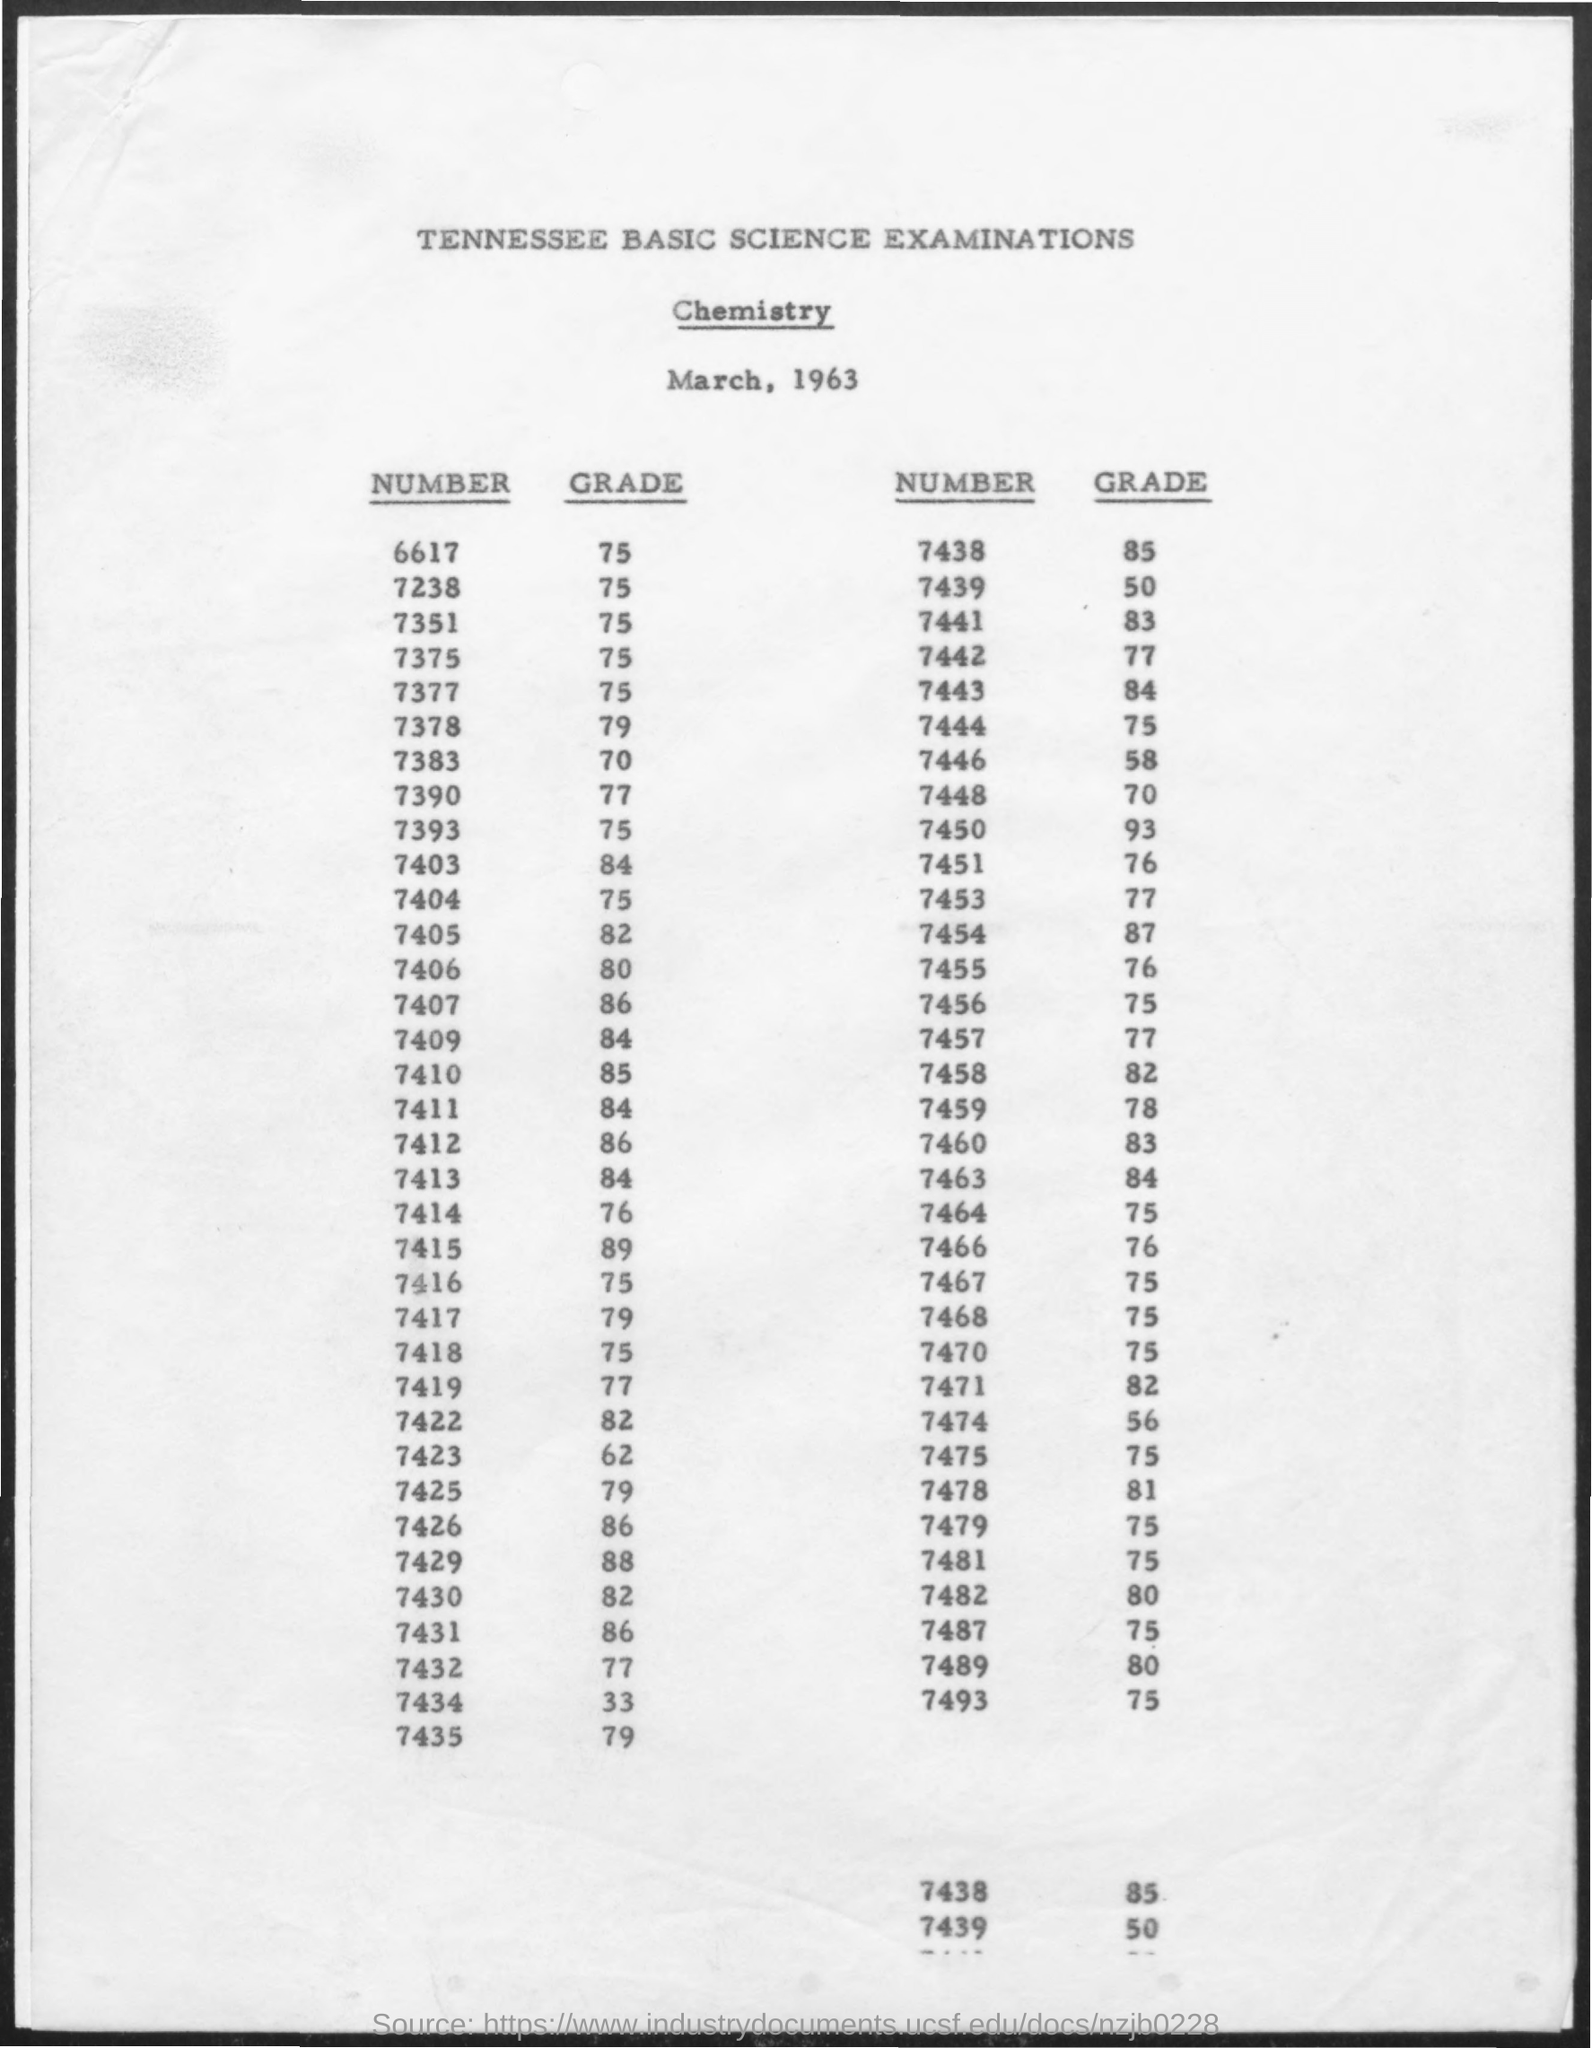what is the grade for the number 7438 ? The grade for the number 7438 is 85, as indicated on the Tennessee Basic Science Examinations Chemistry score sheet from March, 1963. 